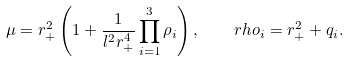Convert formula to latex. <formula><loc_0><loc_0><loc_500><loc_500>\mu = r _ { + } ^ { 2 } \left ( 1 + \frac { 1 } { l ^ { 2 } r _ { + } ^ { 4 } } \prod _ { i = 1 } ^ { 3 } \rho _ { i } \right ) , \quad r h o _ { i } = r _ { + } ^ { 2 } + q _ { i } .</formula> 